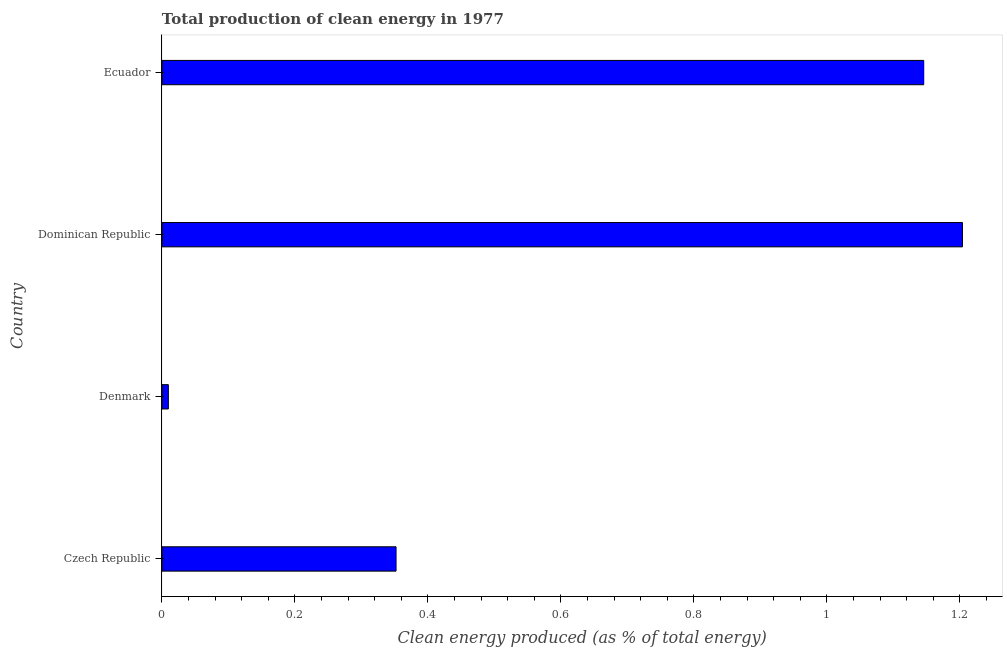Does the graph contain any zero values?
Provide a succinct answer. No. Does the graph contain grids?
Offer a terse response. No. What is the title of the graph?
Ensure brevity in your answer.  Total production of clean energy in 1977. What is the label or title of the X-axis?
Keep it short and to the point. Clean energy produced (as % of total energy). What is the production of clean energy in Dominican Republic?
Your answer should be very brief. 1.2. Across all countries, what is the maximum production of clean energy?
Ensure brevity in your answer.  1.2. Across all countries, what is the minimum production of clean energy?
Your response must be concise. 0.01. In which country was the production of clean energy maximum?
Your response must be concise. Dominican Republic. In which country was the production of clean energy minimum?
Give a very brief answer. Denmark. What is the sum of the production of clean energy?
Your answer should be very brief. 2.71. What is the difference between the production of clean energy in Czech Republic and Denmark?
Keep it short and to the point. 0.34. What is the average production of clean energy per country?
Make the answer very short. 0.68. What is the median production of clean energy?
Keep it short and to the point. 0.75. What is the ratio of the production of clean energy in Czech Republic to that in Ecuador?
Give a very brief answer. 0.31. Is the production of clean energy in Denmark less than that in Ecuador?
Your answer should be very brief. Yes. Is the difference between the production of clean energy in Czech Republic and Dominican Republic greater than the difference between any two countries?
Ensure brevity in your answer.  No. What is the difference between the highest and the second highest production of clean energy?
Provide a succinct answer. 0.06. Is the sum of the production of clean energy in Czech Republic and Dominican Republic greater than the maximum production of clean energy across all countries?
Your answer should be compact. Yes. What is the difference between the highest and the lowest production of clean energy?
Your answer should be very brief. 1.19. How many bars are there?
Keep it short and to the point. 4. Are all the bars in the graph horizontal?
Keep it short and to the point. Yes. How many countries are there in the graph?
Keep it short and to the point. 4. What is the Clean energy produced (as % of total energy) of Czech Republic?
Make the answer very short. 0.35. What is the Clean energy produced (as % of total energy) of Denmark?
Your answer should be compact. 0.01. What is the Clean energy produced (as % of total energy) in Dominican Republic?
Offer a terse response. 1.2. What is the Clean energy produced (as % of total energy) in Ecuador?
Keep it short and to the point. 1.15. What is the difference between the Clean energy produced (as % of total energy) in Czech Republic and Denmark?
Ensure brevity in your answer.  0.34. What is the difference between the Clean energy produced (as % of total energy) in Czech Republic and Dominican Republic?
Keep it short and to the point. -0.85. What is the difference between the Clean energy produced (as % of total energy) in Czech Republic and Ecuador?
Your answer should be compact. -0.79. What is the difference between the Clean energy produced (as % of total energy) in Denmark and Dominican Republic?
Your answer should be compact. -1.19. What is the difference between the Clean energy produced (as % of total energy) in Denmark and Ecuador?
Offer a terse response. -1.14. What is the difference between the Clean energy produced (as % of total energy) in Dominican Republic and Ecuador?
Your response must be concise. 0.06. What is the ratio of the Clean energy produced (as % of total energy) in Czech Republic to that in Denmark?
Provide a succinct answer. 36.27. What is the ratio of the Clean energy produced (as % of total energy) in Czech Republic to that in Dominican Republic?
Keep it short and to the point. 0.29. What is the ratio of the Clean energy produced (as % of total energy) in Czech Republic to that in Ecuador?
Make the answer very short. 0.31. What is the ratio of the Clean energy produced (as % of total energy) in Denmark to that in Dominican Republic?
Make the answer very short. 0.01. What is the ratio of the Clean energy produced (as % of total energy) in Denmark to that in Ecuador?
Your answer should be compact. 0.01. What is the ratio of the Clean energy produced (as % of total energy) in Dominican Republic to that in Ecuador?
Your answer should be compact. 1.05. 